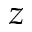Convert formula to latex. <formula><loc_0><loc_0><loc_500><loc_500>z</formula> 